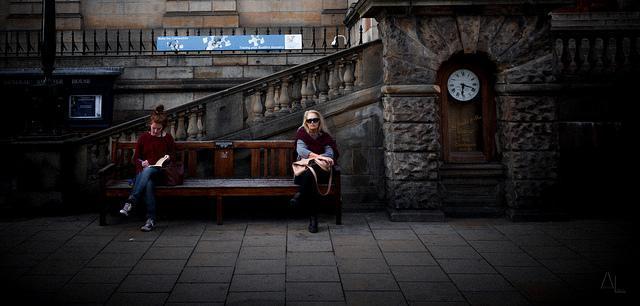How many people are there?
Give a very brief answer. 2. How many people are in the photo?
Give a very brief answer. 2. 